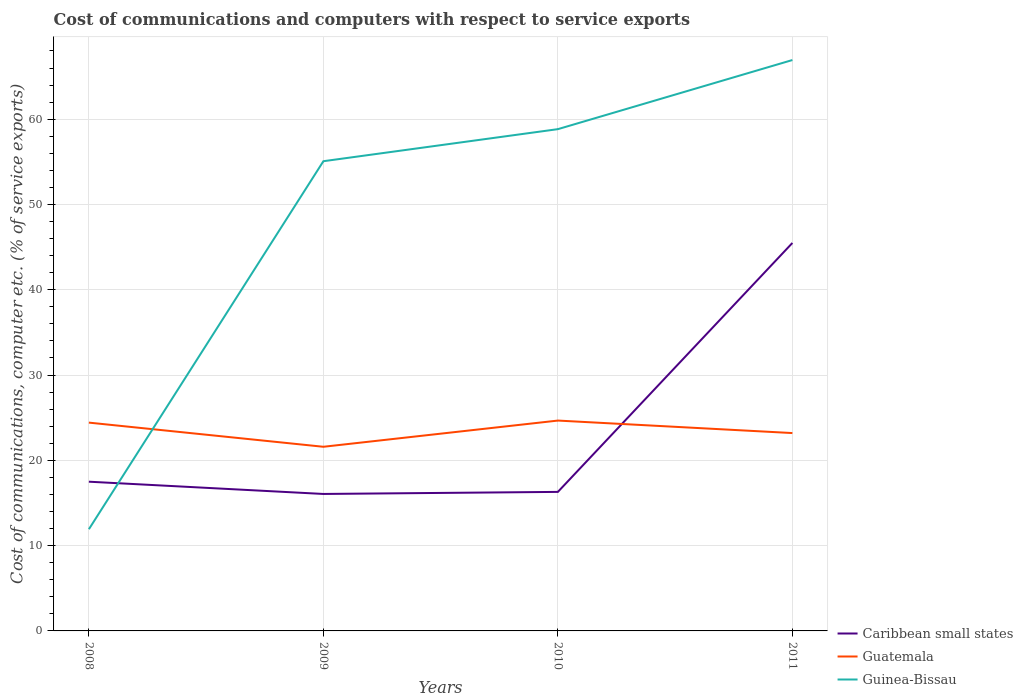Does the line corresponding to Caribbean small states intersect with the line corresponding to Guinea-Bissau?
Ensure brevity in your answer.  Yes. Across all years, what is the maximum cost of communications and computers in Caribbean small states?
Provide a short and direct response. 16.06. In which year was the cost of communications and computers in Caribbean small states maximum?
Keep it short and to the point. 2009. What is the total cost of communications and computers in Guatemala in the graph?
Your answer should be very brief. 1.47. What is the difference between the highest and the second highest cost of communications and computers in Caribbean small states?
Give a very brief answer. 29.43. What is the title of the graph?
Your response must be concise. Cost of communications and computers with respect to service exports. What is the label or title of the Y-axis?
Your answer should be very brief. Cost of communications, computer etc. (% of service exports). What is the Cost of communications, computer etc. (% of service exports) of Caribbean small states in 2008?
Make the answer very short. 17.5. What is the Cost of communications, computer etc. (% of service exports) of Guatemala in 2008?
Give a very brief answer. 24.42. What is the Cost of communications, computer etc. (% of service exports) in Guinea-Bissau in 2008?
Offer a very short reply. 11.93. What is the Cost of communications, computer etc. (% of service exports) in Caribbean small states in 2009?
Ensure brevity in your answer.  16.06. What is the Cost of communications, computer etc. (% of service exports) of Guatemala in 2009?
Keep it short and to the point. 21.59. What is the Cost of communications, computer etc. (% of service exports) of Guinea-Bissau in 2009?
Your answer should be compact. 55.07. What is the Cost of communications, computer etc. (% of service exports) in Caribbean small states in 2010?
Give a very brief answer. 16.3. What is the Cost of communications, computer etc. (% of service exports) of Guatemala in 2010?
Your response must be concise. 24.66. What is the Cost of communications, computer etc. (% of service exports) in Guinea-Bissau in 2010?
Ensure brevity in your answer.  58.83. What is the Cost of communications, computer etc. (% of service exports) of Caribbean small states in 2011?
Your answer should be compact. 45.49. What is the Cost of communications, computer etc. (% of service exports) in Guatemala in 2011?
Offer a very short reply. 23.2. What is the Cost of communications, computer etc. (% of service exports) in Guinea-Bissau in 2011?
Offer a very short reply. 66.94. Across all years, what is the maximum Cost of communications, computer etc. (% of service exports) in Caribbean small states?
Offer a terse response. 45.49. Across all years, what is the maximum Cost of communications, computer etc. (% of service exports) of Guatemala?
Offer a very short reply. 24.66. Across all years, what is the maximum Cost of communications, computer etc. (% of service exports) in Guinea-Bissau?
Offer a terse response. 66.94. Across all years, what is the minimum Cost of communications, computer etc. (% of service exports) in Caribbean small states?
Your response must be concise. 16.06. Across all years, what is the minimum Cost of communications, computer etc. (% of service exports) in Guatemala?
Make the answer very short. 21.59. Across all years, what is the minimum Cost of communications, computer etc. (% of service exports) in Guinea-Bissau?
Ensure brevity in your answer.  11.93. What is the total Cost of communications, computer etc. (% of service exports) in Caribbean small states in the graph?
Offer a very short reply. 95.34. What is the total Cost of communications, computer etc. (% of service exports) of Guatemala in the graph?
Your response must be concise. 93.88. What is the total Cost of communications, computer etc. (% of service exports) of Guinea-Bissau in the graph?
Offer a terse response. 192.77. What is the difference between the Cost of communications, computer etc. (% of service exports) in Caribbean small states in 2008 and that in 2009?
Your answer should be compact. 1.44. What is the difference between the Cost of communications, computer etc. (% of service exports) in Guatemala in 2008 and that in 2009?
Make the answer very short. 2.83. What is the difference between the Cost of communications, computer etc. (% of service exports) of Guinea-Bissau in 2008 and that in 2009?
Your response must be concise. -43.15. What is the difference between the Cost of communications, computer etc. (% of service exports) in Caribbean small states in 2008 and that in 2010?
Provide a short and direct response. 1.19. What is the difference between the Cost of communications, computer etc. (% of service exports) in Guatemala in 2008 and that in 2010?
Ensure brevity in your answer.  -0.24. What is the difference between the Cost of communications, computer etc. (% of service exports) in Guinea-Bissau in 2008 and that in 2010?
Your answer should be compact. -46.91. What is the difference between the Cost of communications, computer etc. (% of service exports) of Caribbean small states in 2008 and that in 2011?
Offer a very short reply. -27.99. What is the difference between the Cost of communications, computer etc. (% of service exports) in Guatemala in 2008 and that in 2011?
Your answer should be very brief. 1.22. What is the difference between the Cost of communications, computer etc. (% of service exports) of Guinea-Bissau in 2008 and that in 2011?
Your response must be concise. -55.01. What is the difference between the Cost of communications, computer etc. (% of service exports) in Caribbean small states in 2009 and that in 2010?
Your answer should be very brief. -0.24. What is the difference between the Cost of communications, computer etc. (% of service exports) in Guatemala in 2009 and that in 2010?
Provide a short and direct response. -3.07. What is the difference between the Cost of communications, computer etc. (% of service exports) of Guinea-Bissau in 2009 and that in 2010?
Offer a terse response. -3.76. What is the difference between the Cost of communications, computer etc. (% of service exports) of Caribbean small states in 2009 and that in 2011?
Your answer should be very brief. -29.43. What is the difference between the Cost of communications, computer etc. (% of service exports) of Guatemala in 2009 and that in 2011?
Make the answer very short. -1.61. What is the difference between the Cost of communications, computer etc. (% of service exports) of Guinea-Bissau in 2009 and that in 2011?
Your answer should be very brief. -11.86. What is the difference between the Cost of communications, computer etc. (% of service exports) of Caribbean small states in 2010 and that in 2011?
Offer a very short reply. -29.19. What is the difference between the Cost of communications, computer etc. (% of service exports) in Guatemala in 2010 and that in 2011?
Your answer should be compact. 1.47. What is the difference between the Cost of communications, computer etc. (% of service exports) of Guinea-Bissau in 2010 and that in 2011?
Offer a very short reply. -8.1. What is the difference between the Cost of communications, computer etc. (% of service exports) of Caribbean small states in 2008 and the Cost of communications, computer etc. (% of service exports) of Guatemala in 2009?
Provide a succinct answer. -4.1. What is the difference between the Cost of communications, computer etc. (% of service exports) of Caribbean small states in 2008 and the Cost of communications, computer etc. (% of service exports) of Guinea-Bissau in 2009?
Keep it short and to the point. -37.58. What is the difference between the Cost of communications, computer etc. (% of service exports) of Guatemala in 2008 and the Cost of communications, computer etc. (% of service exports) of Guinea-Bissau in 2009?
Provide a short and direct response. -30.65. What is the difference between the Cost of communications, computer etc. (% of service exports) in Caribbean small states in 2008 and the Cost of communications, computer etc. (% of service exports) in Guatemala in 2010?
Keep it short and to the point. -7.17. What is the difference between the Cost of communications, computer etc. (% of service exports) of Caribbean small states in 2008 and the Cost of communications, computer etc. (% of service exports) of Guinea-Bissau in 2010?
Ensure brevity in your answer.  -41.34. What is the difference between the Cost of communications, computer etc. (% of service exports) in Guatemala in 2008 and the Cost of communications, computer etc. (% of service exports) in Guinea-Bissau in 2010?
Offer a very short reply. -34.41. What is the difference between the Cost of communications, computer etc. (% of service exports) in Caribbean small states in 2008 and the Cost of communications, computer etc. (% of service exports) in Guatemala in 2011?
Keep it short and to the point. -5.7. What is the difference between the Cost of communications, computer etc. (% of service exports) of Caribbean small states in 2008 and the Cost of communications, computer etc. (% of service exports) of Guinea-Bissau in 2011?
Your response must be concise. -49.44. What is the difference between the Cost of communications, computer etc. (% of service exports) in Guatemala in 2008 and the Cost of communications, computer etc. (% of service exports) in Guinea-Bissau in 2011?
Provide a succinct answer. -42.51. What is the difference between the Cost of communications, computer etc. (% of service exports) of Caribbean small states in 2009 and the Cost of communications, computer etc. (% of service exports) of Guatemala in 2010?
Offer a terse response. -8.61. What is the difference between the Cost of communications, computer etc. (% of service exports) in Caribbean small states in 2009 and the Cost of communications, computer etc. (% of service exports) in Guinea-Bissau in 2010?
Ensure brevity in your answer.  -42.77. What is the difference between the Cost of communications, computer etc. (% of service exports) in Guatemala in 2009 and the Cost of communications, computer etc. (% of service exports) in Guinea-Bissau in 2010?
Give a very brief answer. -37.24. What is the difference between the Cost of communications, computer etc. (% of service exports) in Caribbean small states in 2009 and the Cost of communications, computer etc. (% of service exports) in Guatemala in 2011?
Give a very brief answer. -7.14. What is the difference between the Cost of communications, computer etc. (% of service exports) of Caribbean small states in 2009 and the Cost of communications, computer etc. (% of service exports) of Guinea-Bissau in 2011?
Your answer should be compact. -50.88. What is the difference between the Cost of communications, computer etc. (% of service exports) in Guatemala in 2009 and the Cost of communications, computer etc. (% of service exports) in Guinea-Bissau in 2011?
Offer a very short reply. -45.34. What is the difference between the Cost of communications, computer etc. (% of service exports) in Caribbean small states in 2010 and the Cost of communications, computer etc. (% of service exports) in Guatemala in 2011?
Offer a very short reply. -6.9. What is the difference between the Cost of communications, computer etc. (% of service exports) in Caribbean small states in 2010 and the Cost of communications, computer etc. (% of service exports) in Guinea-Bissau in 2011?
Provide a short and direct response. -50.63. What is the difference between the Cost of communications, computer etc. (% of service exports) in Guatemala in 2010 and the Cost of communications, computer etc. (% of service exports) in Guinea-Bissau in 2011?
Your answer should be very brief. -42.27. What is the average Cost of communications, computer etc. (% of service exports) of Caribbean small states per year?
Ensure brevity in your answer.  23.84. What is the average Cost of communications, computer etc. (% of service exports) in Guatemala per year?
Your answer should be compact. 23.47. What is the average Cost of communications, computer etc. (% of service exports) in Guinea-Bissau per year?
Ensure brevity in your answer.  48.19. In the year 2008, what is the difference between the Cost of communications, computer etc. (% of service exports) of Caribbean small states and Cost of communications, computer etc. (% of service exports) of Guatemala?
Keep it short and to the point. -6.93. In the year 2008, what is the difference between the Cost of communications, computer etc. (% of service exports) in Caribbean small states and Cost of communications, computer etc. (% of service exports) in Guinea-Bissau?
Provide a succinct answer. 5.57. In the year 2008, what is the difference between the Cost of communications, computer etc. (% of service exports) in Guatemala and Cost of communications, computer etc. (% of service exports) in Guinea-Bissau?
Your response must be concise. 12.5. In the year 2009, what is the difference between the Cost of communications, computer etc. (% of service exports) of Caribbean small states and Cost of communications, computer etc. (% of service exports) of Guatemala?
Provide a short and direct response. -5.53. In the year 2009, what is the difference between the Cost of communications, computer etc. (% of service exports) of Caribbean small states and Cost of communications, computer etc. (% of service exports) of Guinea-Bissau?
Your answer should be very brief. -39.01. In the year 2009, what is the difference between the Cost of communications, computer etc. (% of service exports) of Guatemala and Cost of communications, computer etc. (% of service exports) of Guinea-Bissau?
Ensure brevity in your answer.  -33.48. In the year 2010, what is the difference between the Cost of communications, computer etc. (% of service exports) of Caribbean small states and Cost of communications, computer etc. (% of service exports) of Guatemala?
Give a very brief answer. -8.36. In the year 2010, what is the difference between the Cost of communications, computer etc. (% of service exports) in Caribbean small states and Cost of communications, computer etc. (% of service exports) in Guinea-Bissau?
Ensure brevity in your answer.  -42.53. In the year 2010, what is the difference between the Cost of communications, computer etc. (% of service exports) in Guatemala and Cost of communications, computer etc. (% of service exports) in Guinea-Bissau?
Keep it short and to the point. -34.17. In the year 2011, what is the difference between the Cost of communications, computer etc. (% of service exports) in Caribbean small states and Cost of communications, computer etc. (% of service exports) in Guatemala?
Your response must be concise. 22.29. In the year 2011, what is the difference between the Cost of communications, computer etc. (% of service exports) in Caribbean small states and Cost of communications, computer etc. (% of service exports) in Guinea-Bissau?
Your answer should be very brief. -21.45. In the year 2011, what is the difference between the Cost of communications, computer etc. (% of service exports) in Guatemala and Cost of communications, computer etc. (% of service exports) in Guinea-Bissau?
Ensure brevity in your answer.  -43.74. What is the ratio of the Cost of communications, computer etc. (% of service exports) in Caribbean small states in 2008 to that in 2009?
Your answer should be compact. 1.09. What is the ratio of the Cost of communications, computer etc. (% of service exports) of Guatemala in 2008 to that in 2009?
Ensure brevity in your answer.  1.13. What is the ratio of the Cost of communications, computer etc. (% of service exports) in Guinea-Bissau in 2008 to that in 2009?
Your answer should be compact. 0.22. What is the ratio of the Cost of communications, computer etc. (% of service exports) of Caribbean small states in 2008 to that in 2010?
Offer a very short reply. 1.07. What is the ratio of the Cost of communications, computer etc. (% of service exports) of Guatemala in 2008 to that in 2010?
Offer a very short reply. 0.99. What is the ratio of the Cost of communications, computer etc. (% of service exports) in Guinea-Bissau in 2008 to that in 2010?
Your response must be concise. 0.2. What is the ratio of the Cost of communications, computer etc. (% of service exports) of Caribbean small states in 2008 to that in 2011?
Your answer should be compact. 0.38. What is the ratio of the Cost of communications, computer etc. (% of service exports) in Guatemala in 2008 to that in 2011?
Provide a short and direct response. 1.05. What is the ratio of the Cost of communications, computer etc. (% of service exports) in Guinea-Bissau in 2008 to that in 2011?
Your answer should be very brief. 0.18. What is the ratio of the Cost of communications, computer etc. (% of service exports) of Caribbean small states in 2009 to that in 2010?
Keep it short and to the point. 0.99. What is the ratio of the Cost of communications, computer etc. (% of service exports) in Guatemala in 2009 to that in 2010?
Keep it short and to the point. 0.88. What is the ratio of the Cost of communications, computer etc. (% of service exports) of Guinea-Bissau in 2009 to that in 2010?
Make the answer very short. 0.94. What is the ratio of the Cost of communications, computer etc. (% of service exports) of Caribbean small states in 2009 to that in 2011?
Make the answer very short. 0.35. What is the ratio of the Cost of communications, computer etc. (% of service exports) in Guatemala in 2009 to that in 2011?
Provide a succinct answer. 0.93. What is the ratio of the Cost of communications, computer etc. (% of service exports) of Guinea-Bissau in 2009 to that in 2011?
Ensure brevity in your answer.  0.82. What is the ratio of the Cost of communications, computer etc. (% of service exports) of Caribbean small states in 2010 to that in 2011?
Provide a succinct answer. 0.36. What is the ratio of the Cost of communications, computer etc. (% of service exports) of Guatemala in 2010 to that in 2011?
Your answer should be compact. 1.06. What is the ratio of the Cost of communications, computer etc. (% of service exports) in Guinea-Bissau in 2010 to that in 2011?
Make the answer very short. 0.88. What is the difference between the highest and the second highest Cost of communications, computer etc. (% of service exports) of Caribbean small states?
Your response must be concise. 27.99. What is the difference between the highest and the second highest Cost of communications, computer etc. (% of service exports) in Guatemala?
Make the answer very short. 0.24. What is the difference between the highest and the second highest Cost of communications, computer etc. (% of service exports) of Guinea-Bissau?
Your answer should be compact. 8.1. What is the difference between the highest and the lowest Cost of communications, computer etc. (% of service exports) of Caribbean small states?
Offer a very short reply. 29.43. What is the difference between the highest and the lowest Cost of communications, computer etc. (% of service exports) of Guatemala?
Give a very brief answer. 3.07. What is the difference between the highest and the lowest Cost of communications, computer etc. (% of service exports) of Guinea-Bissau?
Offer a very short reply. 55.01. 